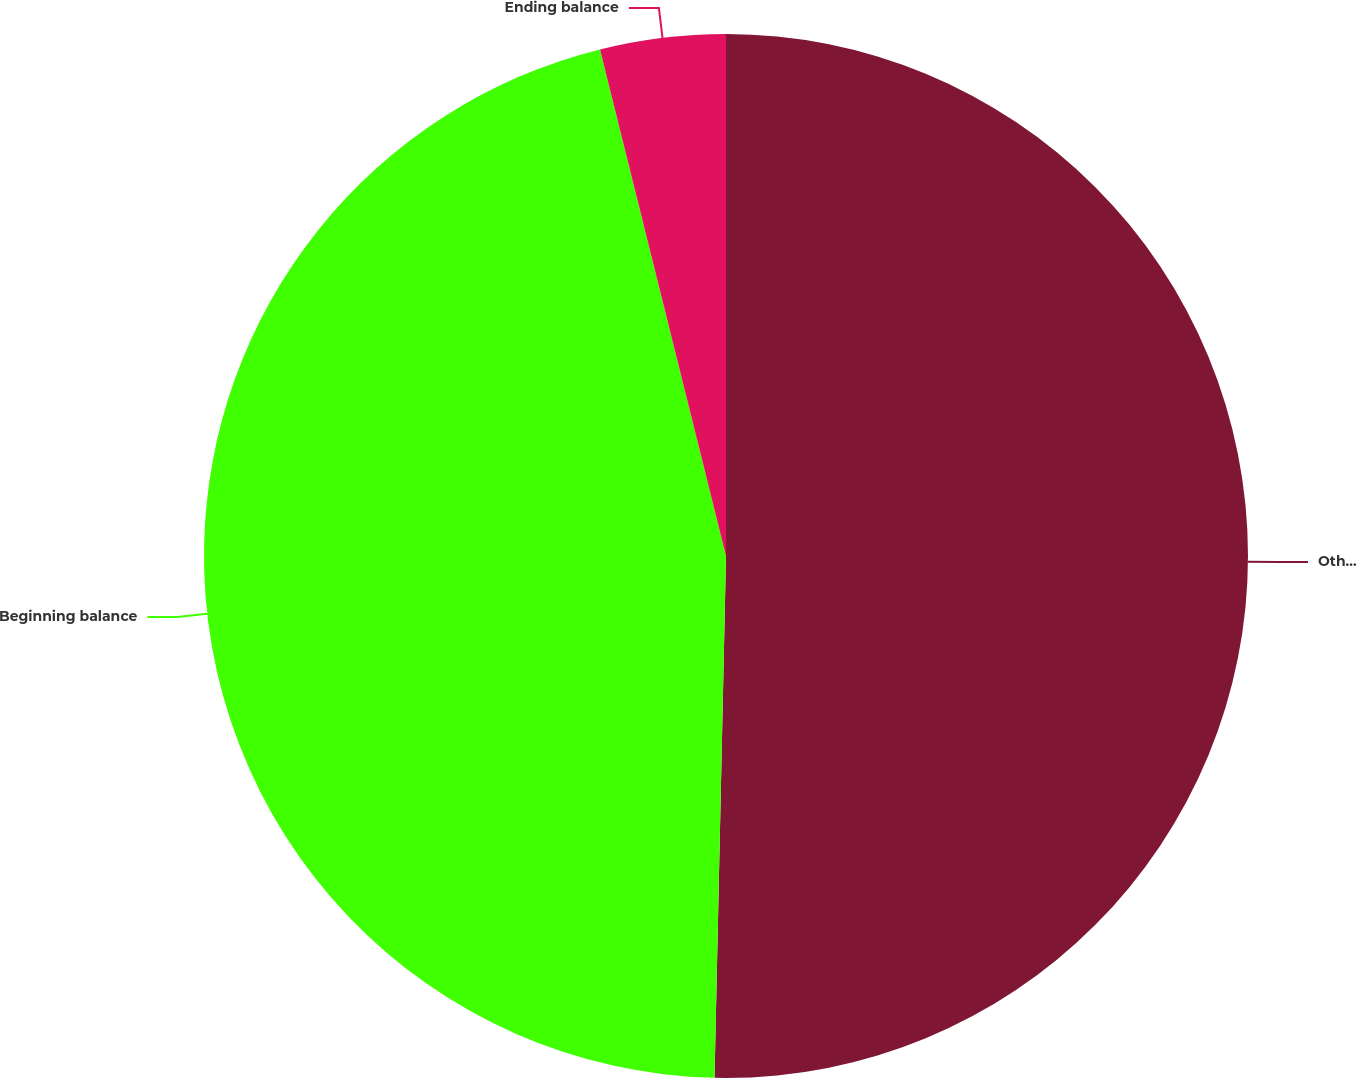Convert chart to OTSL. <chart><loc_0><loc_0><loc_500><loc_500><pie_chart><fcel>Other comprehensive<fcel>Beginning balance<fcel>Ending balance<nl><fcel>50.35%<fcel>45.77%<fcel>3.88%<nl></chart> 